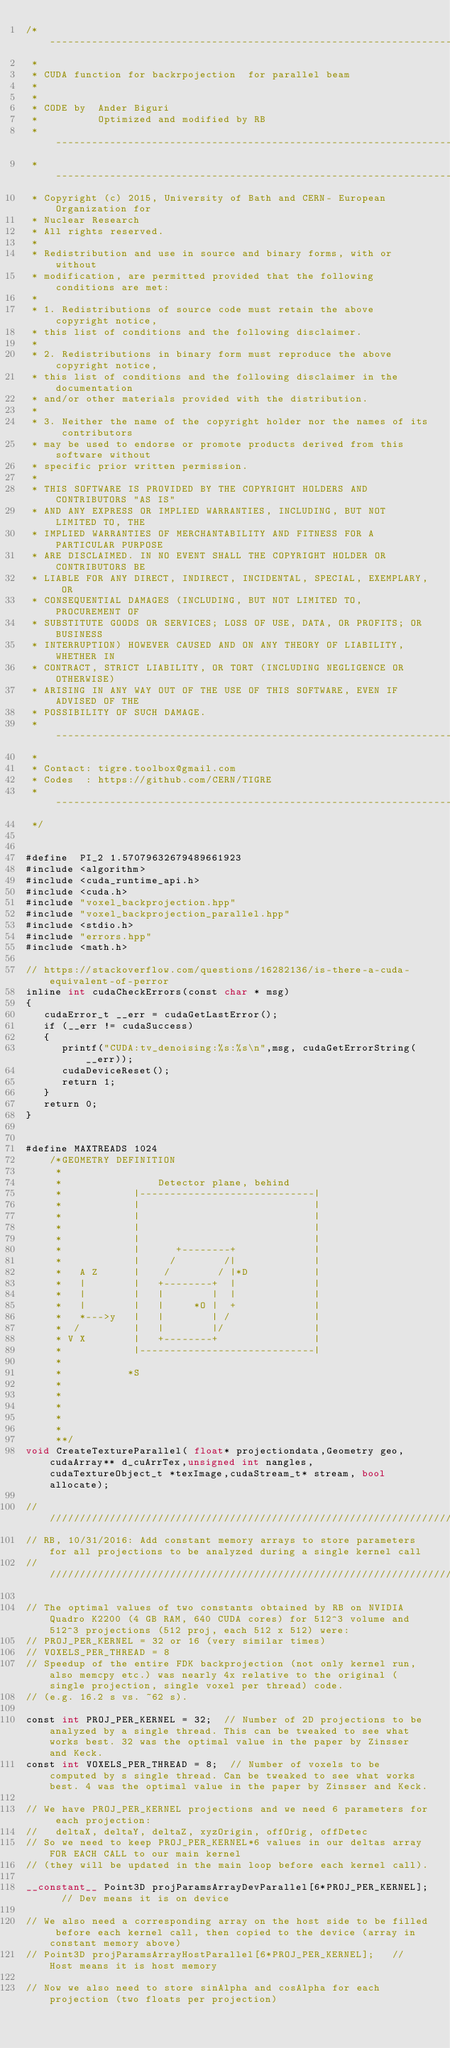Convert code to text. <code><loc_0><loc_0><loc_500><loc_500><_Cuda_>/*-------------------------------------------------------------------------
 *
 * CUDA function for backrpojection  for parallel beam
 *
 *
 * CODE by  Ander Biguri
 *          Optimized and modified by RB
 * ---------------------------------------------------------------------------
 * ---------------------------------------------------------------------------
 * Copyright (c) 2015, University of Bath and CERN- European Organization for
 * Nuclear Research
 * All rights reserved.
 *
 * Redistribution and use in source and binary forms, with or without
 * modification, are permitted provided that the following conditions are met:
 *
 * 1. Redistributions of source code must retain the above copyright notice,
 * this list of conditions and the following disclaimer.
 *
 * 2. Redistributions in binary form must reproduce the above copyright notice,
 * this list of conditions and the following disclaimer in the documentation
 * and/or other materials provided with the distribution.
 *
 * 3. Neither the name of the copyright holder nor the names of its contributors
 * may be used to endorse or promote products derived from this software without
 * specific prior written permission.
 *
 * THIS SOFTWARE IS PROVIDED BY THE COPYRIGHT HOLDERS AND CONTRIBUTORS "AS IS"
 * AND ANY EXPRESS OR IMPLIED WARRANTIES, INCLUDING, BUT NOT LIMITED TO, THE
 * IMPLIED WARRANTIES OF MERCHANTABILITY AND FITNESS FOR A PARTICULAR PURPOSE
 * ARE DISCLAIMED. IN NO EVENT SHALL THE COPYRIGHT HOLDER OR CONTRIBUTORS BE
 * LIABLE FOR ANY DIRECT, INDIRECT, INCIDENTAL, SPECIAL, EXEMPLARY, OR
 * CONSEQUENTIAL DAMAGES (INCLUDING, BUT NOT LIMITED TO, PROCUREMENT OF
 * SUBSTITUTE GOODS OR SERVICES; LOSS OF USE, DATA, OR PROFITS; OR BUSINESS
 * INTERRUPTION) HOWEVER CAUSED AND ON ANY THEORY OF LIABILITY, WHETHER IN
 * CONTRACT, STRICT LIABILITY, OR TORT (INCLUDING NEGLIGENCE OR OTHERWISE)
 * ARISING IN ANY WAY OUT OF THE USE OF THIS SOFTWARE, EVEN IF ADVISED OF THE
 * POSSIBILITY OF SUCH DAMAGE.
 * ---------------------------------------------------------------------------
 *
 * Contact: tigre.toolbox@gmail.com
 * Codes  : https://github.com/CERN/TIGRE
 * ---------------------------------------------------------------------------
 */


#define  PI_2 1.57079632679489661923
#include <algorithm>
#include <cuda_runtime_api.h>
#include <cuda.h>
#include "voxel_backprojection.hpp"
#include "voxel_backprojection_parallel.hpp"
#include <stdio.h>
#include "errors.hpp"
#include <math.h>

// https://stackoverflow.com/questions/16282136/is-there-a-cuda-equivalent-of-perror
inline int cudaCheckErrors(const char * msg)
{
   cudaError_t __err = cudaGetLastError();
   if (__err != cudaSuccess)
   {
      printf("CUDA:tv_denoising:%s:%s\n",msg, cudaGetErrorString(__err));
      cudaDeviceReset();
      return 1;
   }
   return 0;
}
    
    
#define MAXTREADS 1024
    /*GEOMETRY DEFINITION
     *
     *                Detector plane, behind
     *            |-----------------------------|
     *            |                             |
     *            |                             |
     *            |                             |
     *            |                             |
     *            |      +--------+             |
     *            |     /        /|             |
     *   A Z      |    /        / |*D           |
     *   |        |   +--------+  |             |
     *   |        |   |        |  |             |
     *   |        |   |     *O |  +             |
     *   *--->y   |   |        | /              |
     *  /         |   |        |/               |
     * V X        |   +--------+                |
     *            |-----------------------------|
     *
     *           *S
     *
     *
     *
     *
     *
     **/
void CreateTextureParallel( float* projectiondata,Geometry geo,cudaArray** d_cuArrTex,unsigned int nangles, cudaTextureObject_t *texImage,cudaStream_t* stream, bool allocate);

////////////////////////////////////////////////////////////////////////////////////////////////////////////////////////////////
// RB, 10/31/2016: Add constant memory arrays to store parameters for all projections to be analyzed during a single kernel call
////////////////////////////////////////////////////////////////////////////////////////////////////////////////////////////////

// The optimal values of two constants obtained by RB on NVIDIA Quadro K2200 (4 GB RAM, 640 CUDA cores) for 512^3 volume and 512^3 projections (512 proj, each 512 x 512) were:
// PROJ_PER_KERNEL = 32 or 16 (very similar times)
// VOXELS_PER_THREAD = 8
// Speedup of the entire FDK backprojection (not only kernel run, also memcpy etc.) was nearly 4x relative to the original (single projection, single voxel per thread) code.
// (e.g. 16.2 s vs. ~62 s).

const int PROJ_PER_KERNEL = 32;  // Number of 2D projections to be analyzed by a single thread. This can be tweaked to see what works best. 32 was the optimal value in the paper by Zinsser and Keck.
const int VOXELS_PER_THREAD = 8;  // Number of voxels to be computed by s single thread. Can be tweaked to see what works best. 4 was the optimal value in the paper by Zinsser and Keck.

// We have PROJ_PER_KERNEL projections and we need 6 parameters for each projection:
//   deltaX, deltaY, deltaZ, xyzOrigin, offOrig, offDetec
// So we need to keep PROJ_PER_KERNEL*6 values in our deltas array FOR EACH CALL to our main kernel
// (they will be updated in the main loop before each kernel call).

__constant__ Point3D projParamsArrayDevParallel[6*PROJ_PER_KERNEL];  // Dev means it is on device

// We also need a corresponding array on the host side to be filled before each kernel call, then copied to the device (array in constant memory above)
// Point3D projParamsArrayHostParallel[6*PROJ_PER_KERNEL];   // Host means it is host memory

// Now we also need to store sinAlpha and cosAlpha for each projection (two floats per projection)</code> 